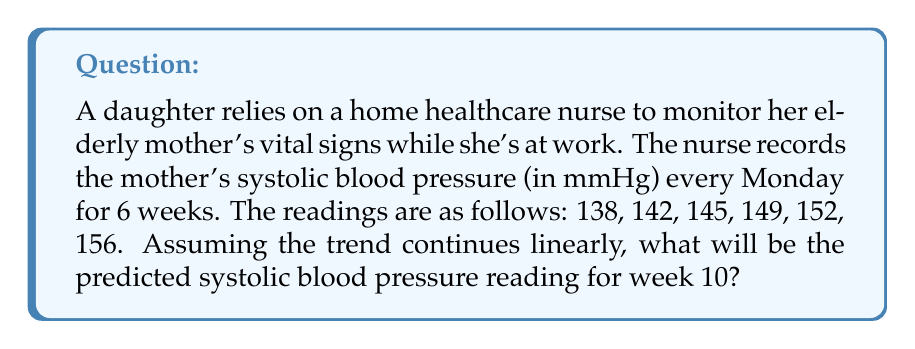Give your solution to this math problem. To solve this problem, we need to find the linear trend in the blood pressure readings and use it to predict the future value. We can use the concept of arithmetic sequences, as the data appears to be increasing at a constant rate.

1. First, let's calculate the common difference (d) between consecutive terms:
   $d = 142 - 138 = 145 - 142 = 149 - 145 = 152 - 149 = 156 - 152 = 4$ mmHg

2. We can confirm that this is indeed an arithmetic sequence with a common difference of 4 mmHg.

3. The general term of an arithmetic sequence is given by:
   $a_n = a_1 + (n-1)d$
   Where $a_n$ is the nth term, $a_1$ is the first term, n is the position, and d is the common difference.

4. In this case:
   $a_1 = 138$ (first reading)
   $d = 4$ (common difference)
   We want to find $a_{10}$ (10th week reading)

5. Plugging these values into the formula:
   $a_{10} = 138 + (10-1)4$
   $a_{10} = 138 + 36$
   $a_{10} = 174$

Therefore, the predicted systolic blood pressure reading for week 10 would be 174 mmHg.
Answer: 174 mmHg 